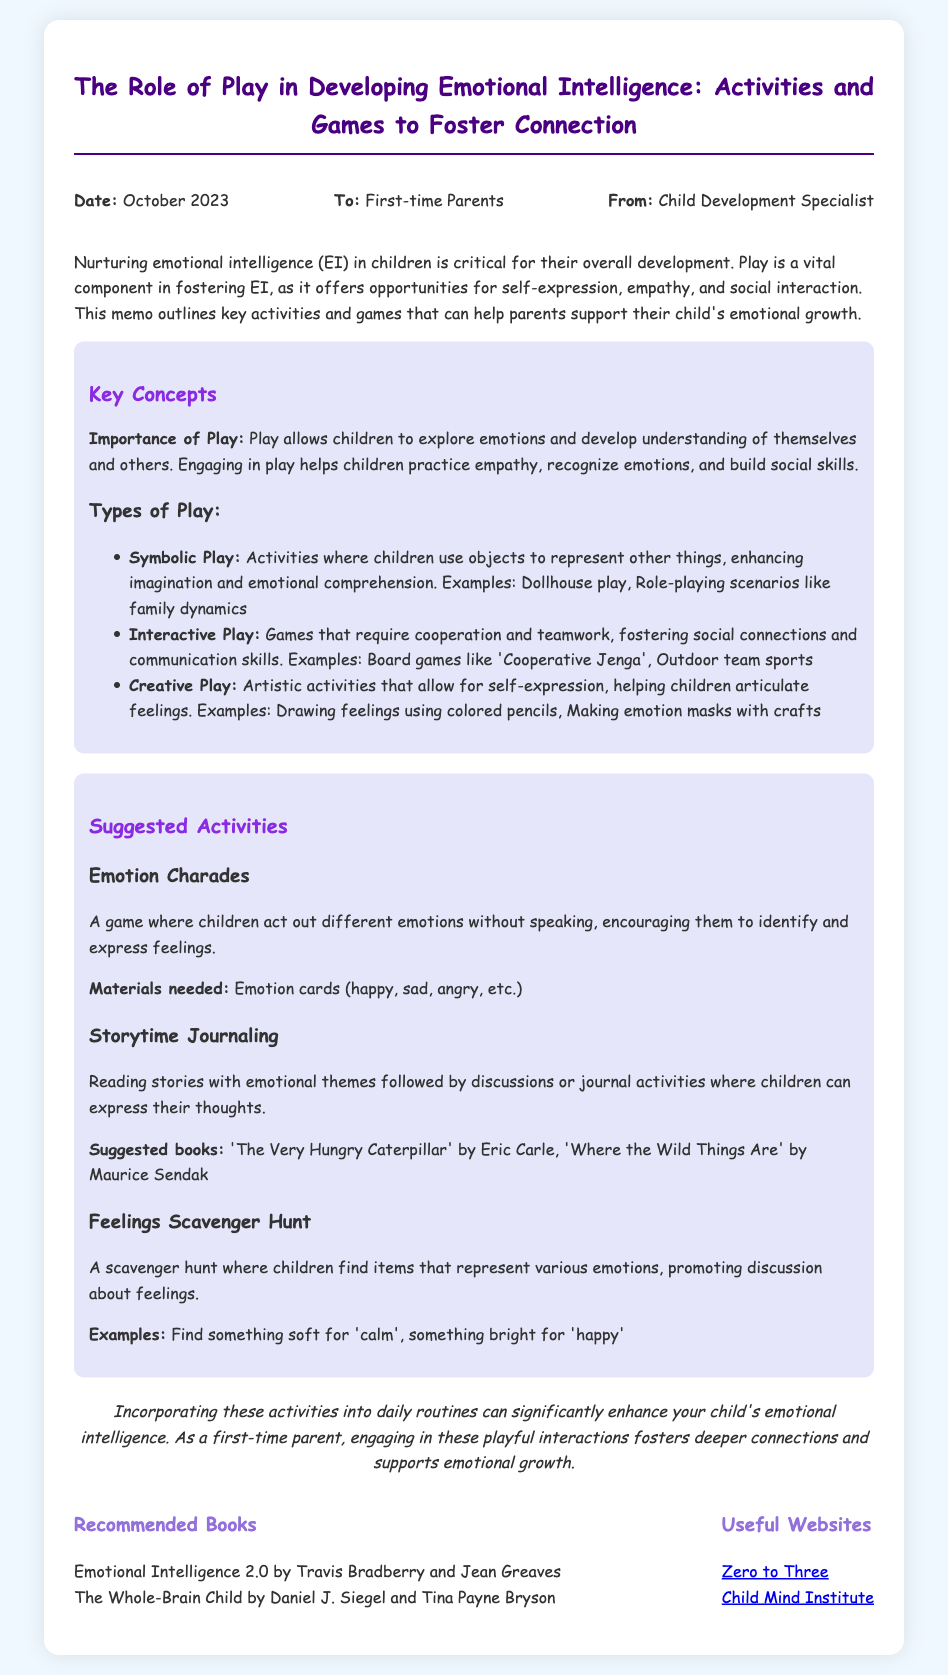What is the date of the memo? The date of the memo is stated at the top section of the document.
Answer: October 2023 Who is the memo addressed to? The memo specifies its audience directly in the header section.
Answer: First-time Parents What are the three types of play mentioned? The document lists the types of play under key concepts with specific examples provided.
Answer: Symbolic Play, Interactive Play, Creative Play What is one activity suggested for fostering emotional intelligence? The memo describes several activities, highlighting them in a dedicated section.
Answer: Emotion Charades What materials are needed for the Emotion Charades game? The materials for activities are outlined in the respective descriptions throughout the document.
Answer: Emotion cards Which book is suggested in the recommended literature? The memo provides a list of recommended books in the resources section.
Answer: Emotional Intelligence 2.0 by Travis Bradberry and Jean Greaves What is the primary purpose of the memo? The introduction of the memo summarizes the intent behind its content.
Answer: Nurturing emotional intelligence What is a suggested book for storytime journaling? Suggested books for specific activities are mentioned in the activities section.
Answer: The Very Hungry Caterpillar by Eric Carle What is the conclusion of the memo focused on? The conclusion summarizes the importance of incorporating activities into parenting routines.
Answer: Enhance your child's emotional intelligence 